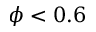Convert formula to latex. <formula><loc_0><loc_0><loc_500><loc_500>\phi < 0 . 6</formula> 